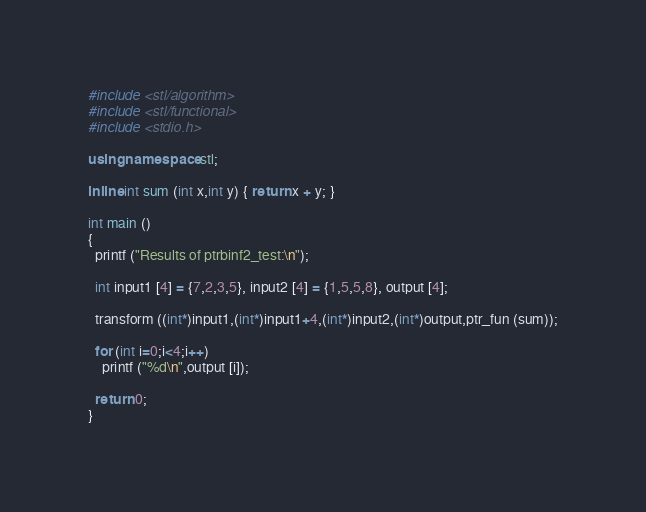Convert code to text. <code><loc_0><loc_0><loc_500><loc_500><_C++_>#include <stl/algorithm>
#include <stl/functional>
#include <stdio.h>

using namespace stl;

inline int sum (int x,int y) { return x + y; }

int main ()
{
  printf ("Results of ptrbinf2_test:\n");

  int input1 [4] = {7,2,3,5}, input2 [4] = {1,5,5,8}, output [4];
  
  transform ((int*)input1,(int*)input1+4,(int*)input2,(int*)output,ptr_fun (sum));
  
  for (int i=0;i<4;i++)
    printf ("%d\n",output [i]);
    
  return 0;
}
</code> 